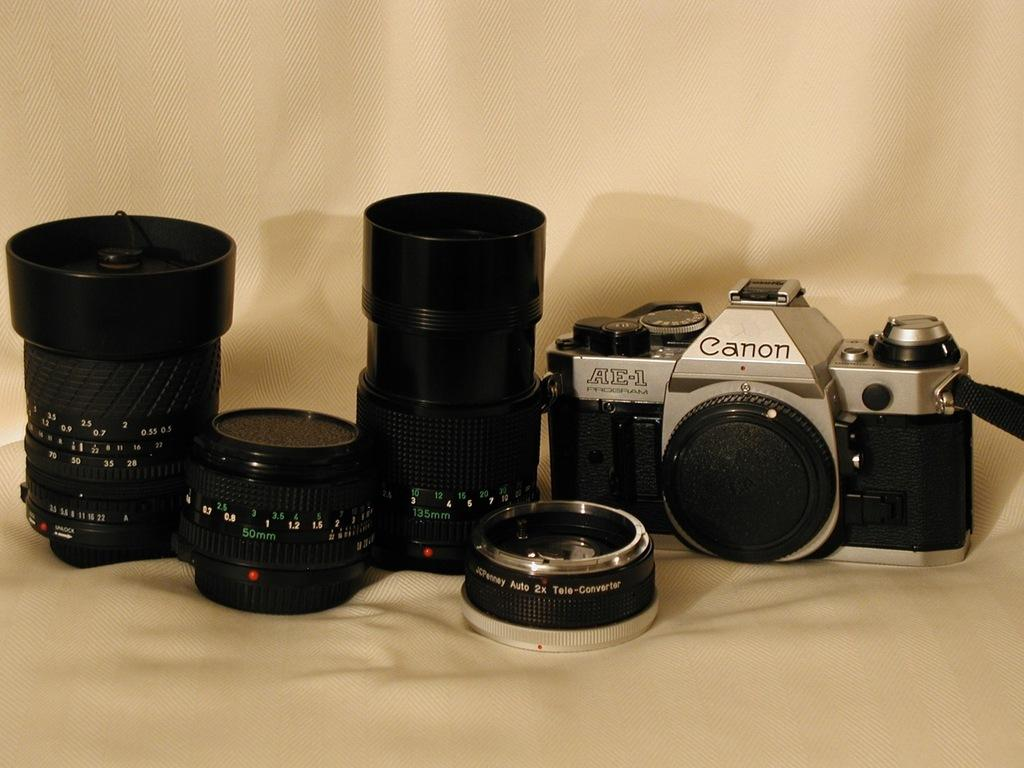What objects are arranged on cloths in the image? There are lenses on the left side of the image and a camera on the right side of the image. What is the color of the background in the image? The background of the image is white in color. What type of vegetable is being used as a prop for the camera in the image? There are no vegetables present in the image; the camera is arranged on a cloth. Can you see a robin perched on the lenses in the image? There are no birds, including robins, present in the image. 